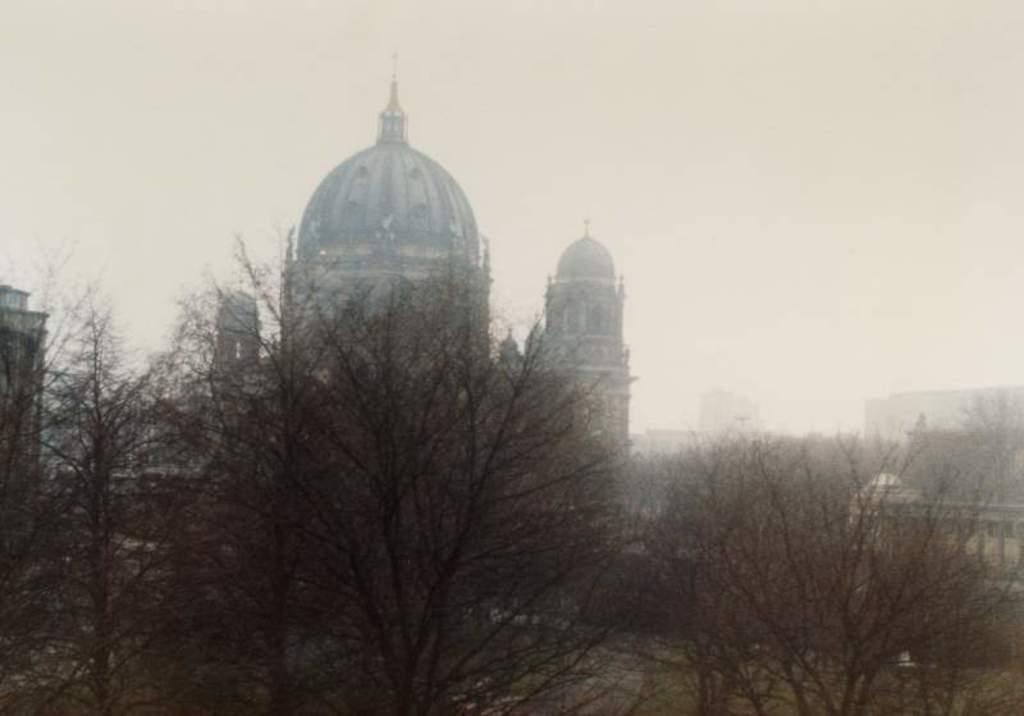How would you summarize this image in a sentence or two? In this picture we can see trees in the front, in the background there are buildings, we can see the sky at the top of the picture. 